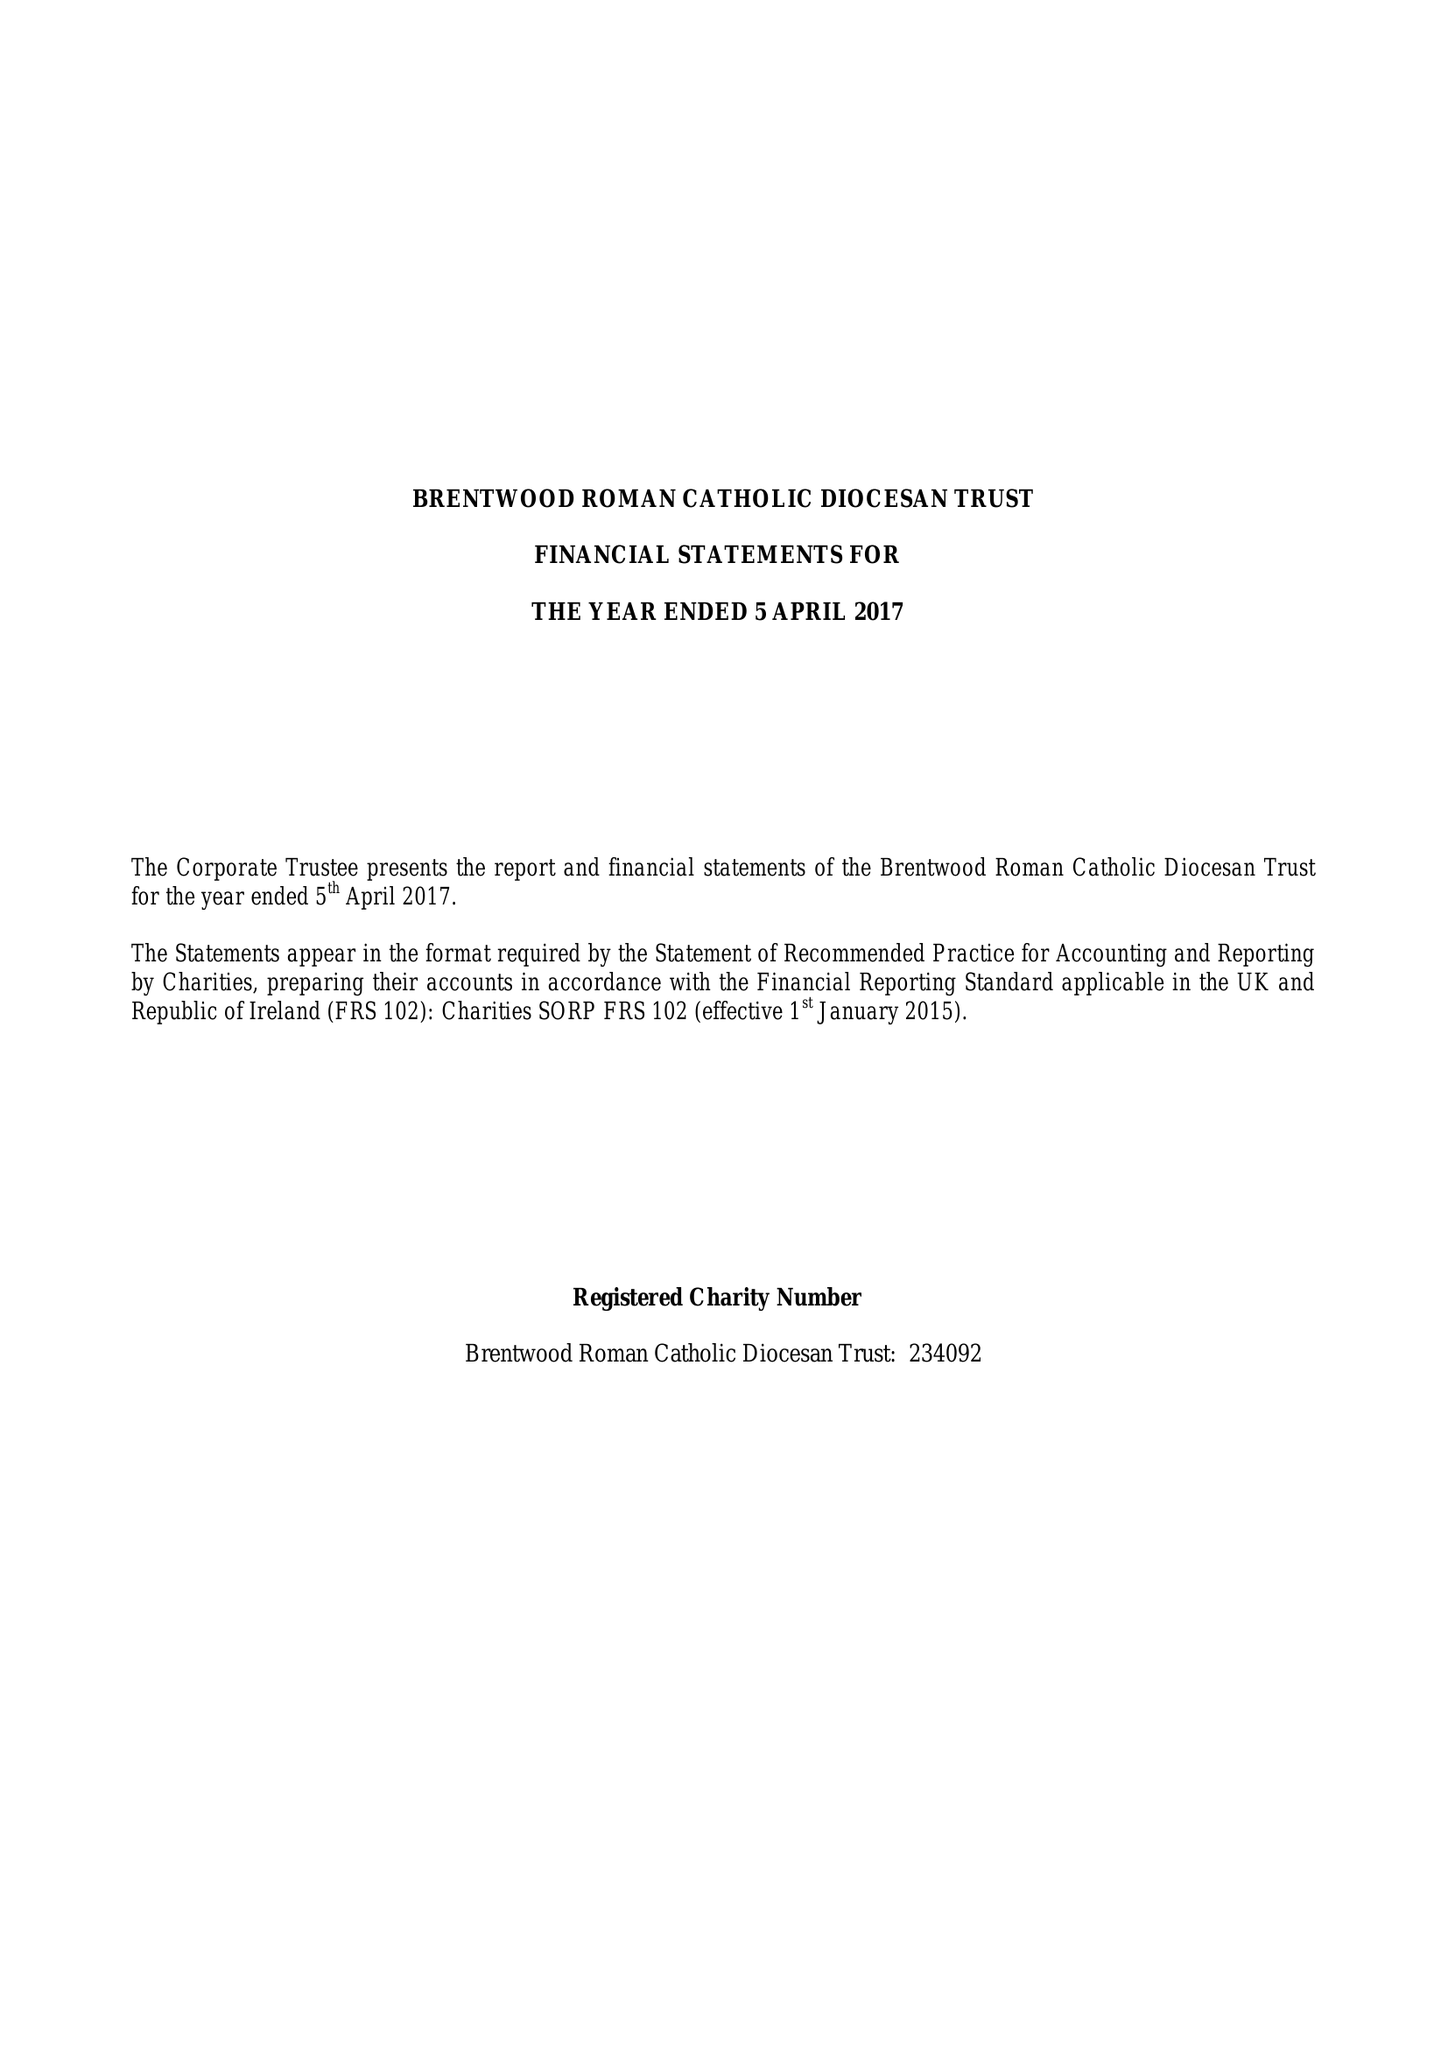What is the value for the address__postcode?
Answer the question using a single word or phrase. CM15 8AT 